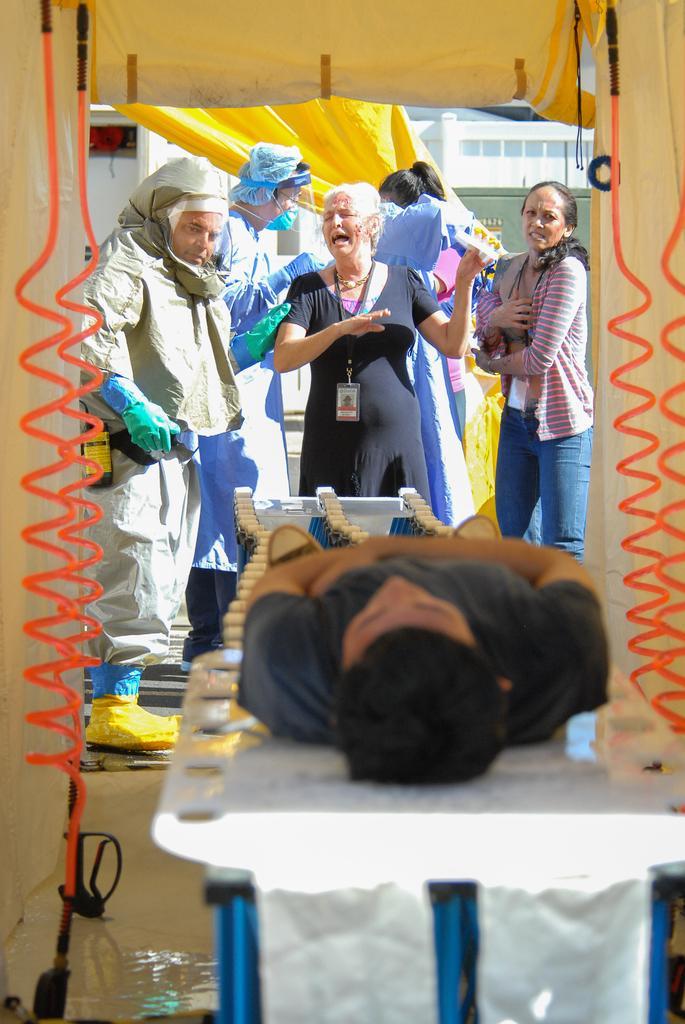Can you describe this image briefly? In this image, we can see people and some are wearing id cards and there are people wearing costumes and gloves and we can see a person lying on the stand and there is a building, a tent, pipes and some other objects. 